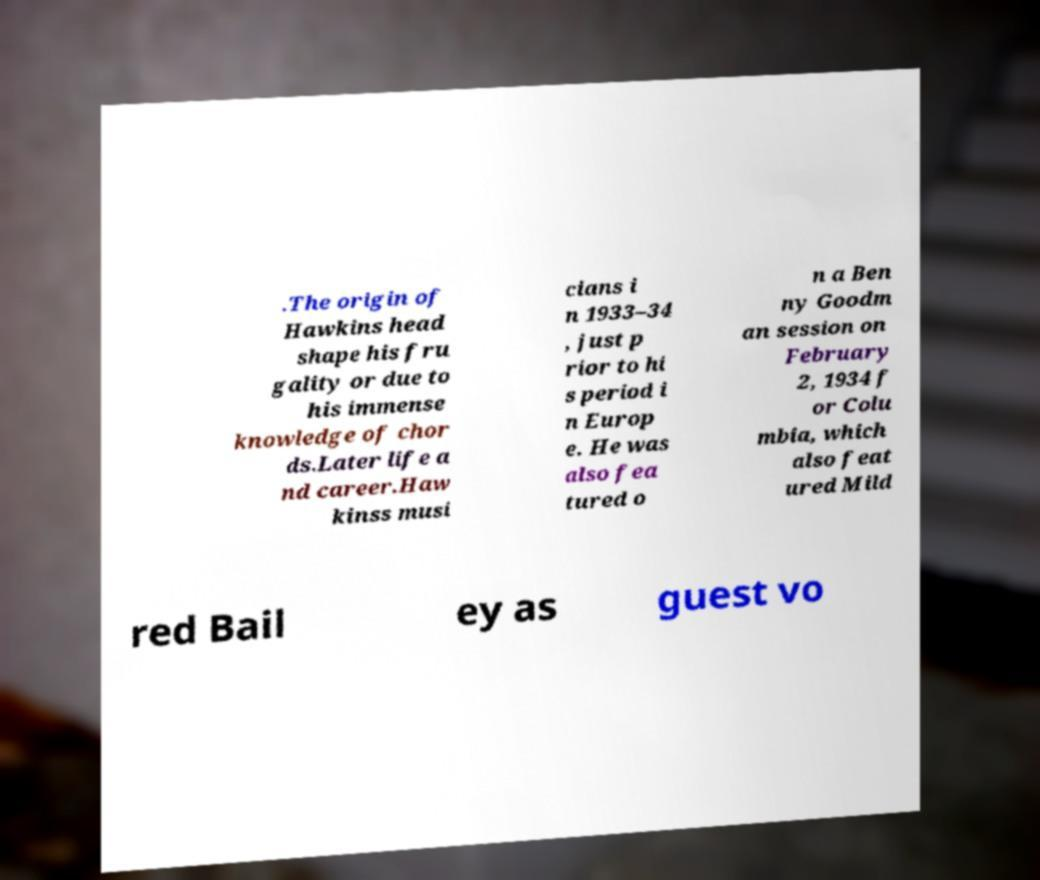I need the written content from this picture converted into text. Can you do that? .The origin of Hawkins head shape his fru gality or due to his immense knowledge of chor ds.Later life a nd career.Haw kinss musi cians i n 1933–34 , just p rior to hi s period i n Europ e. He was also fea tured o n a Ben ny Goodm an session on February 2, 1934 f or Colu mbia, which also feat ured Mild red Bail ey as guest vo 